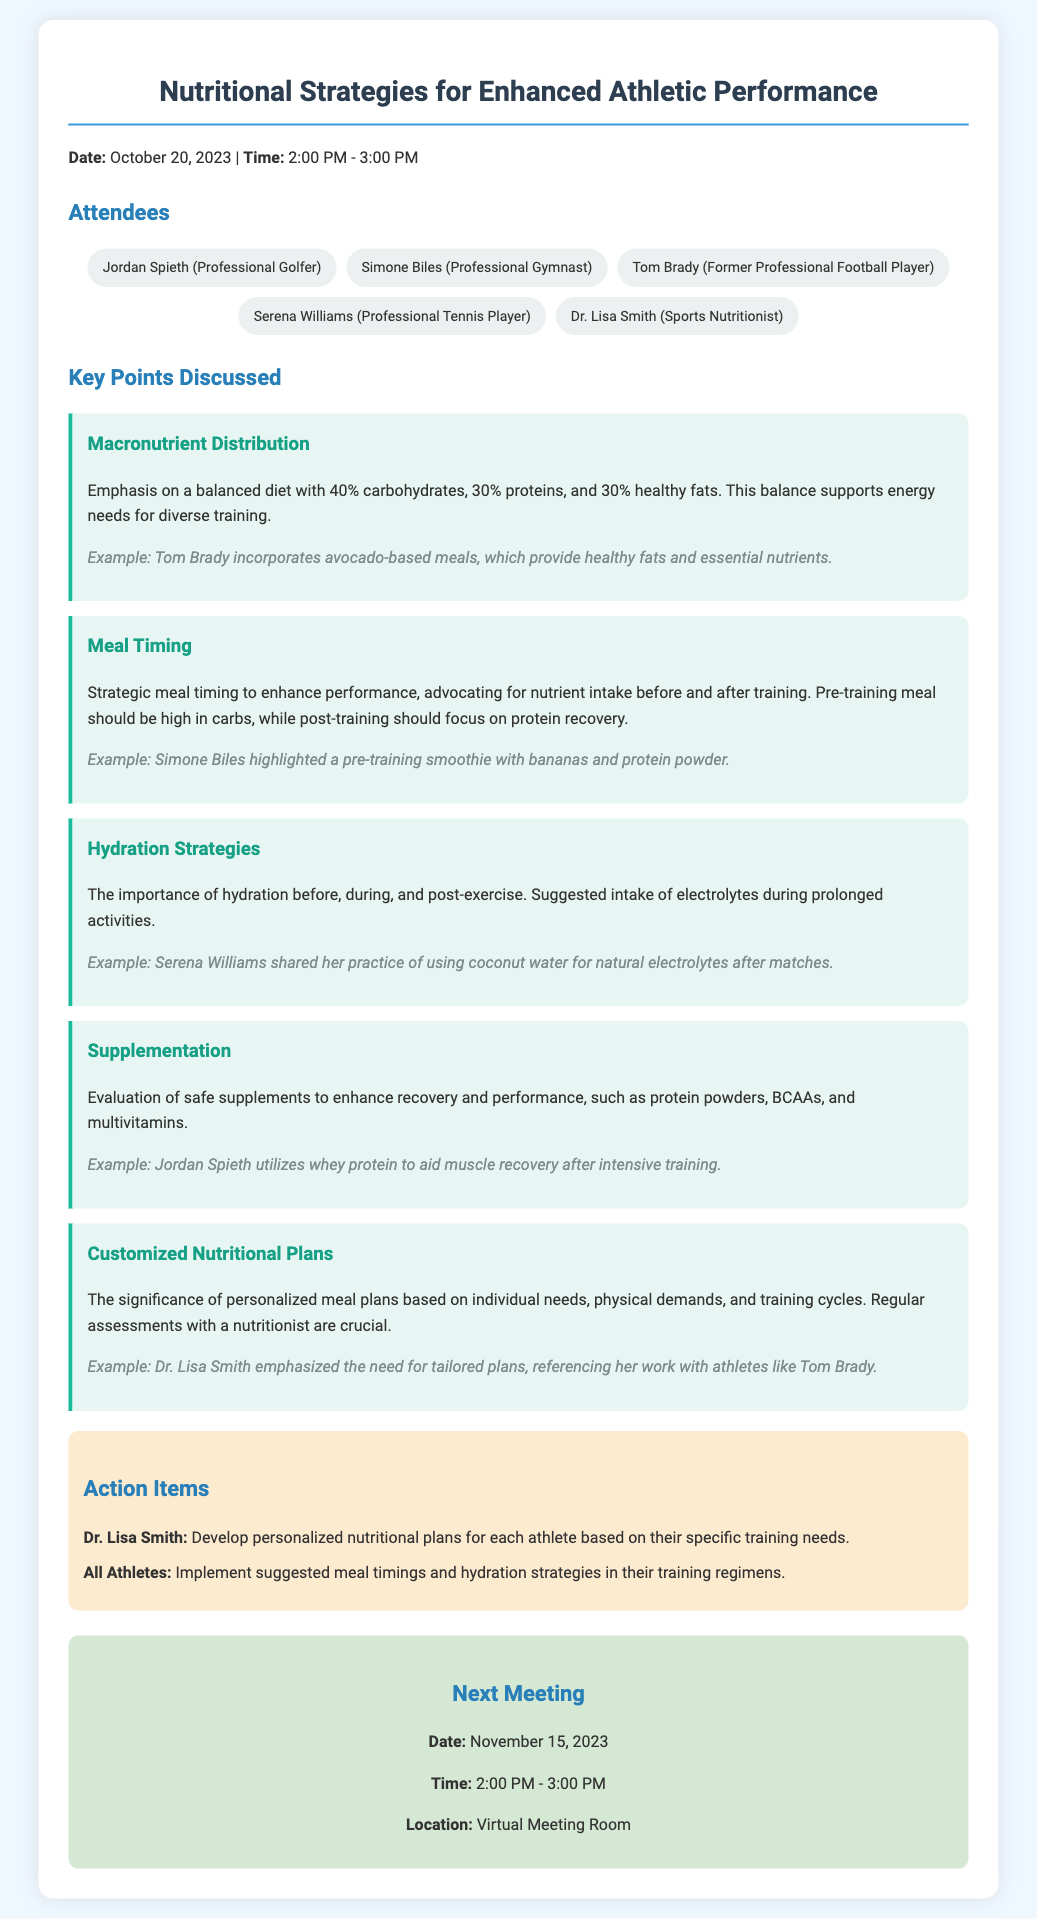What is the date of the meeting? The date of the meeting is mentioned at the beginning of the document.
Answer: October 20, 2023 Who is the sports nutritionist attending the meeting? The attendees are listed in the document, including their professions.
Answer: Dr. Lisa Smith What is the macronutrient distribution discussed for optimal performance? The document provides specific percentages for macronutrient distribution.
Answer: 40% carbohydrates, 30% proteins, 30% healthy fats Which athlete mentioned using coconut water for hydration? An example is given in the hydration strategies section about an athlete's practice.
Answer: Serena Williams What is one of the action items for Dr. Lisa Smith? The action items section outlines specific tasks assigned to attendees.
Answer: Develop personalized nutritional plans for each athlete What type of meal is recommended before training? The meal timing section specifies the characteristics of a pre-training meal.
Answer: High in carbs What should athletes implement in their training regimens? The action items indicate what all athletes are expected to do following the meeting.
Answer: Suggested meal timings and hydration strategies When is the next meeting scheduled? The next meeting's date is mentioned towards the end of the document.
Answer: November 15, 2023 What example did Tom Brady provide regarding his nutritional strategy? The macronutrient distribution section contains an example related to Tom Brady's meals.
Answer: Incorporates avocado-based meals 